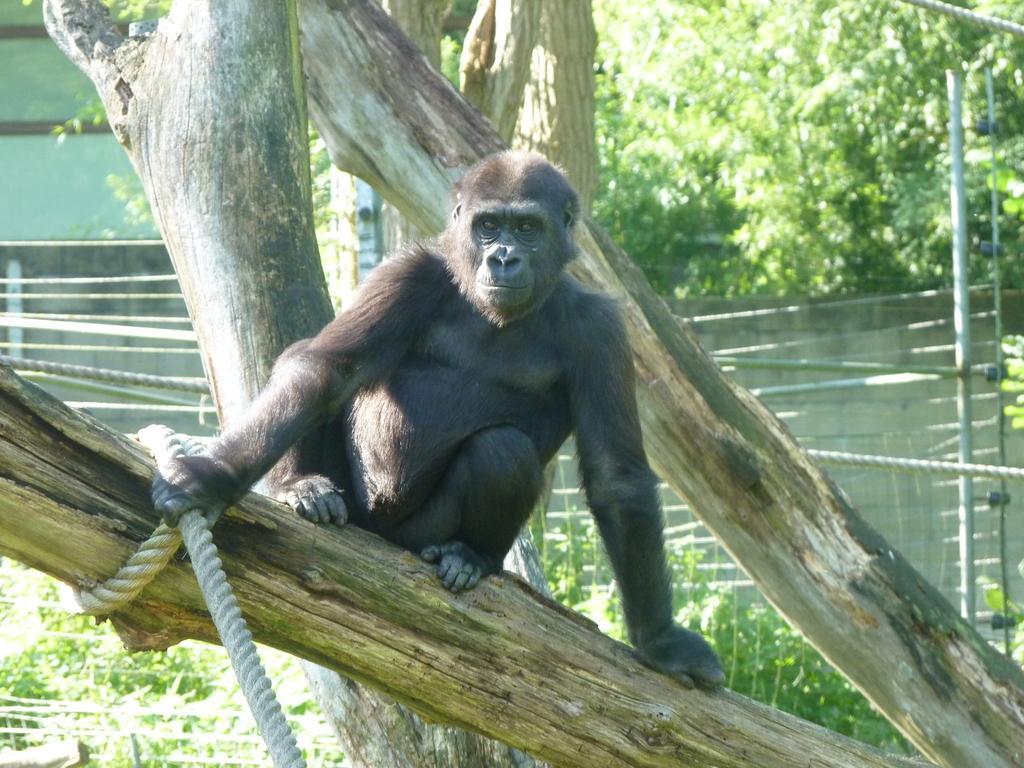Please provide a concise description of this image. In this image we can see a chimpanzee on the branch of a tree, holding white color rope. Background of the image pole, fencing, boundary wall and trees are there. 